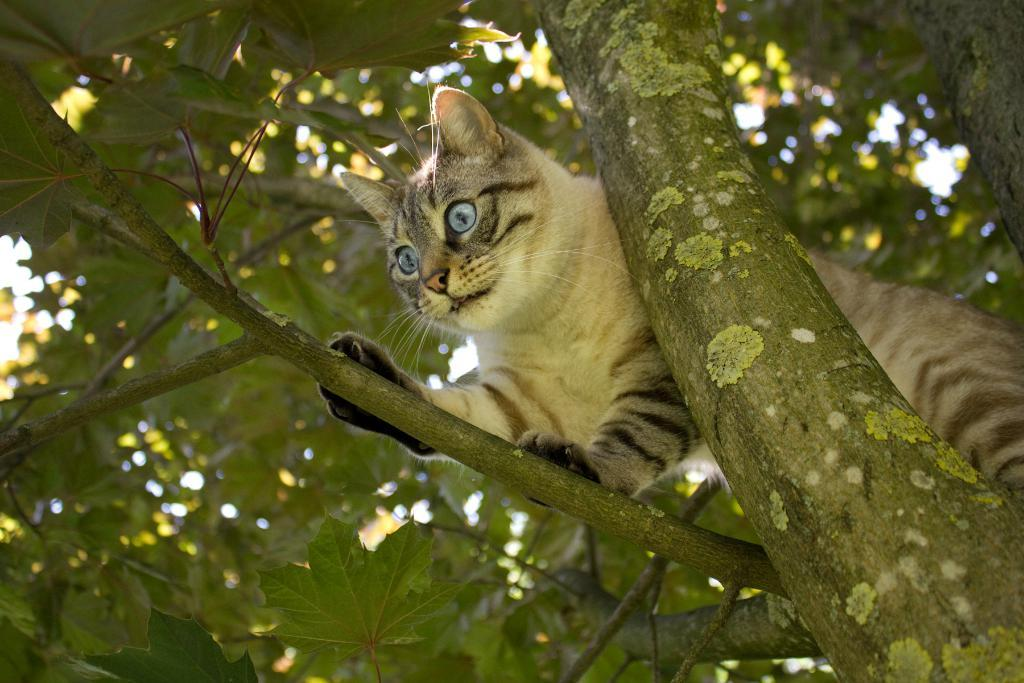What animal is in the image? There is a cat in the image. Where is the cat located? The cat is on a tree stem. What part of the tree can be seen in the image? There is a tree trunk in the image. What can be seen in the background of the image? Leaves and tree stems are visible in the background of the image. How many boys are sitting on the seat in the image? There are no seats or boys present in the image. 